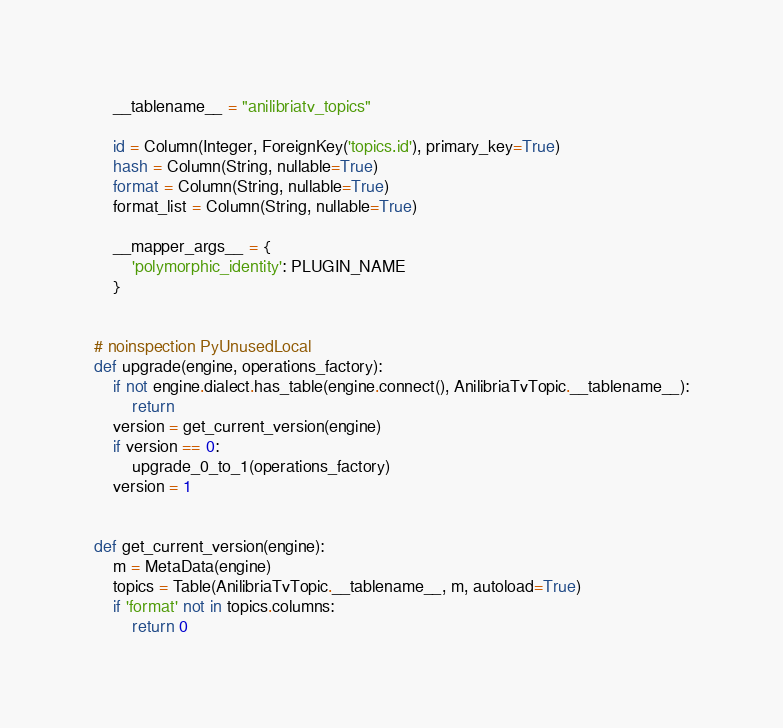Convert code to text. <code><loc_0><loc_0><loc_500><loc_500><_Python_>    __tablename__ = "anilibriatv_topics"

    id = Column(Integer, ForeignKey('topics.id'), primary_key=True)
    hash = Column(String, nullable=True)
    format = Column(String, nullable=True)
    format_list = Column(String, nullable=True)

    __mapper_args__ = {
        'polymorphic_identity': PLUGIN_NAME
    }


# noinspection PyUnusedLocal
def upgrade(engine, operations_factory):
    if not engine.dialect.has_table(engine.connect(), AnilibriaTvTopic.__tablename__):
        return
    version = get_current_version(engine)
    if version == 0:
        upgrade_0_to_1(operations_factory)
    version = 1


def get_current_version(engine):
    m = MetaData(engine)
    topics = Table(AnilibriaTvTopic.__tablename__, m, autoload=True)
    if 'format' not in topics.columns:
        return 0</code> 